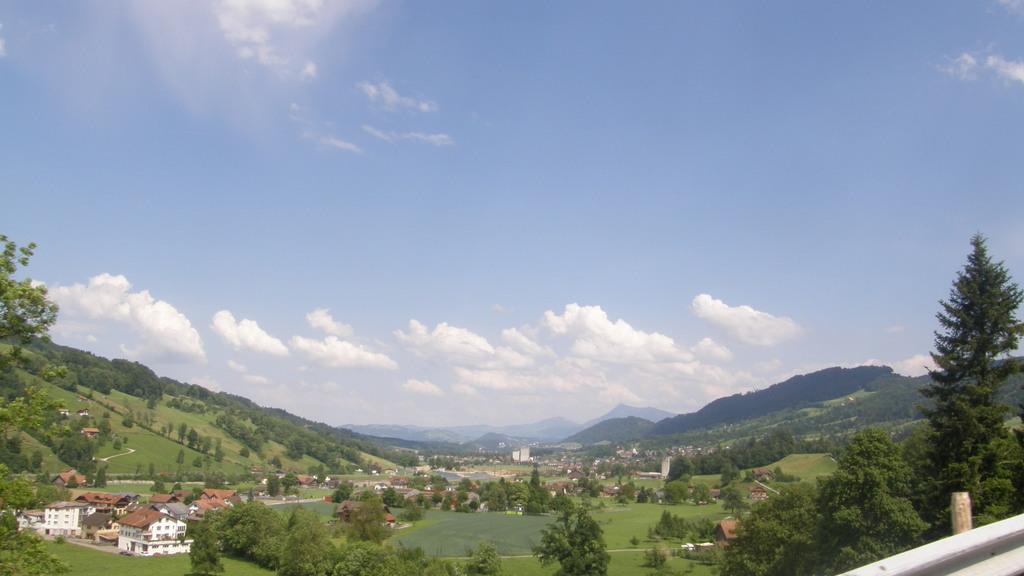Could you give a brief overview of what you see in this image? In this image I can see the grass. On the left side I can see the houses. In the background, I can see the trees and clouds in the sky. 